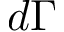Convert formula to latex. <formula><loc_0><loc_0><loc_500><loc_500>d \Gamma</formula> 